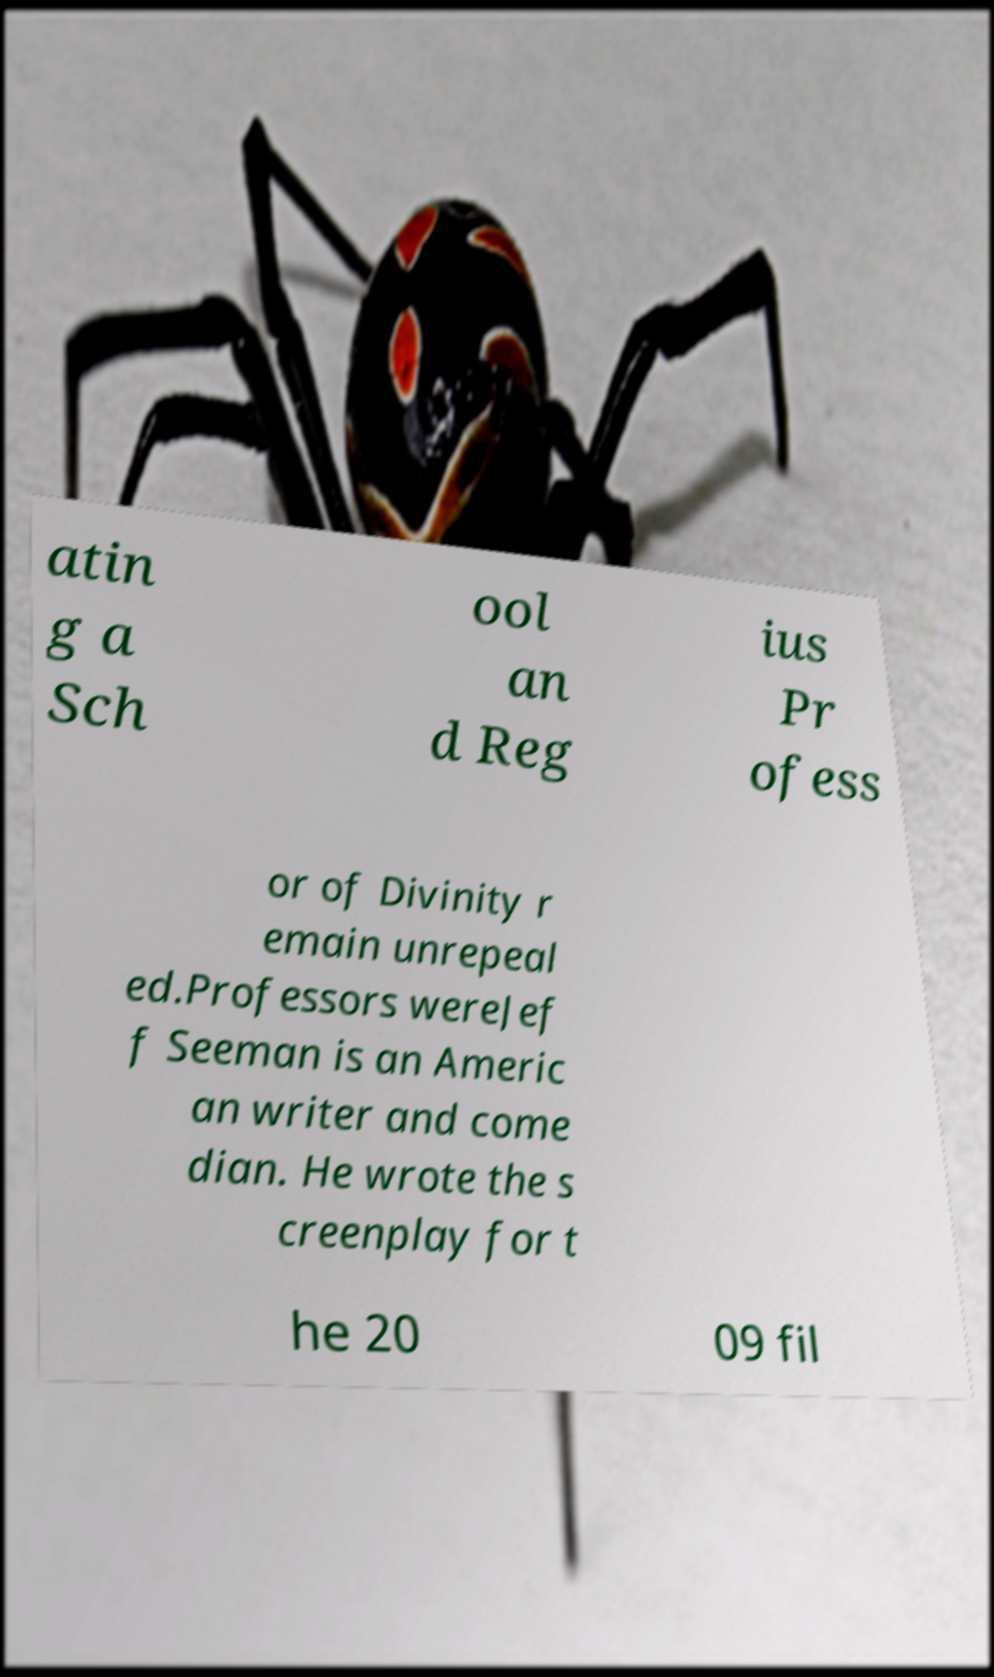Can you accurately transcribe the text from the provided image for me? atin g a Sch ool an d Reg ius Pr ofess or of Divinity r emain unrepeal ed.Professors wereJef f Seeman is an Americ an writer and come dian. He wrote the s creenplay for t he 20 09 fil 